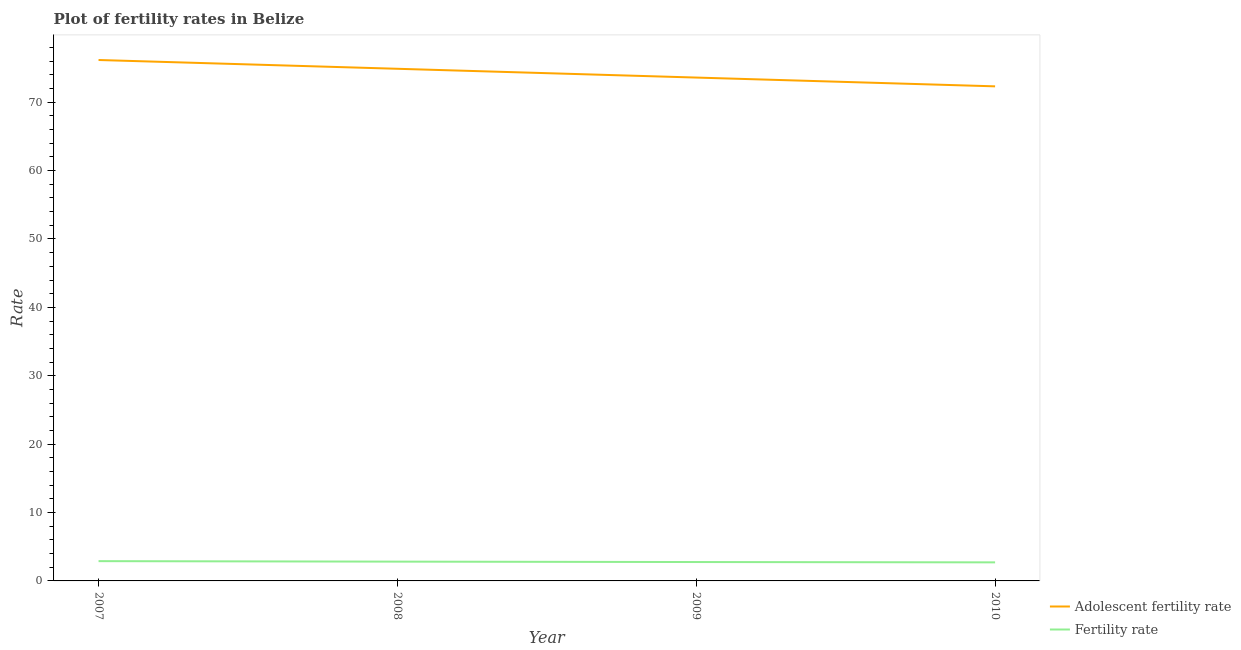How many different coloured lines are there?
Provide a short and direct response. 2. What is the fertility rate in 2009?
Your response must be concise. 2.76. Across all years, what is the maximum fertility rate?
Provide a succinct answer. 2.89. Across all years, what is the minimum fertility rate?
Your answer should be compact. 2.71. In which year was the fertility rate minimum?
Provide a succinct answer. 2010. What is the total adolescent fertility rate in the graph?
Provide a succinct answer. 296.97. What is the difference between the fertility rate in 2008 and that in 2010?
Your answer should be very brief. 0.11. What is the difference between the adolescent fertility rate in 2007 and the fertility rate in 2008?
Give a very brief answer. 73.35. What is the average adolescent fertility rate per year?
Keep it short and to the point. 74.24. In the year 2009, what is the difference between the fertility rate and adolescent fertility rate?
Provide a succinct answer. -70.84. In how many years, is the adolescent fertility rate greater than 2?
Ensure brevity in your answer.  4. What is the ratio of the adolescent fertility rate in 2009 to that in 2010?
Offer a very short reply. 1.02. What is the difference between the highest and the second highest adolescent fertility rate?
Give a very brief answer. 1.28. What is the difference between the highest and the lowest fertility rate?
Provide a short and direct response. 0.18. Is the sum of the adolescent fertility rate in 2007 and 2008 greater than the maximum fertility rate across all years?
Your response must be concise. Yes. Is the adolescent fertility rate strictly greater than the fertility rate over the years?
Provide a succinct answer. Yes. How many years are there in the graph?
Your response must be concise. 4. Does the graph contain any zero values?
Your response must be concise. No. Does the graph contain grids?
Provide a succinct answer. No. How many legend labels are there?
Your response must be concise. 2. What is the title of the graph?
Offer a terse response. Plot of fertility rates in Belize. What is the label or title of the Y-axis?
Offer a terse response. Rate. What is the Rate in Adolescent fertility rate in 2007?
Give a very brief answer. 76.17. What is the Rate in Fertility rate in 2007?
Provide a short and direct response. 2.89. What is the Rate in Adolescent fertility rate in 2008?
Keep it short and to the point. 74.89. What is the Rate in Fertility rate in 2008?
Provide a short and direct response. 2.82. What is the Rate in Adolescent fertility rate in 2009?
Give a very brief answer. 73.6. What is the Rate of Fertility rate in 2009?
Your answer should be very brief. 2.76. What is the Rate of Adolescent fertility rate in 2010?
Offer a terse response. 72.32. What is the Rate in Fertility rate in 2010?
Offer a terse response. 2.71. Across all years, what is the maximum Rate of Adolescent fertility rate?
Provide a short and direct response. 76.17. Across all years, what is the maximum Rate in Fertility rate?
Provide a succinct answer. 2.89. Across all years, what is the minimum Rate in Adolescent fertility rate?
Your answer should be compact. 72.32. Across all years, what is the minimum Rate in Fertility rate?
Offer a terse response. 2.71. What is the total Rate in Adolescent fertility rate in the graph?
Offer a very short reply. 296.97. What is the total Rate in Fertility rate in the graph?
Provide a short and direct response. 11.19. What is the difference between the Rate of Adolescent fertility rate in 2007 and that in 2008?
Provide a short and direct response. 1.28. What is the difference between the Rate in Fertility rate in 2007 and that in 2008?
Give a very brief answer. 0.07. What is the difference between the Rate of Adolescent fertility rate in 2007 and that in 2009?
Give a very brief answer. 2.57. What is the difference between the Rate of Fertility rate in 2007 and that in 2009?
Make the answer very short. 0.13. What is the difference between the Rate in Adolescent fertility rate in 2007 and that in 2010?
Offer a very short reply. 3.85. What is the difference between the Rate in Fertility rate in 2007 and that in 2010?
Give a very brief answer. 0.18. What is the difference between the Rate in Adolescent fertility rate in 2008 and that in 2009?
Offer a terse response. 1.28. What is the difference between the Rate in Fertility rate in 2008 and that in 2009?
Ensure brevity in your answer.  0.06. What is the difference between the Rate of Adolescent fertility rate in 2008 and that in 2010?
Offer a terse response. 2.57. What is the difference between the Rate of Fertility rate in 2008 and that in 2010?
Provide a succinct answer. 0.11. What is the difference between the Rate of Adolescent fertility rate in 2009 and that in 2010?
Offer a very short reply. 1.28. What is the difference between the Rate of Fertility rate in 2009 and that in 2010?
Your answer should be compact. 0.05. What is the difference between the Rate in Adolescent fertility rate in 2007 and the Rate in Fertility rate in 2008?
Your answer should be compact. 73.35. What is the difference between the Rate of Adolescent fertility rate in 2007 and the Rate of Fertility rate in 2009?
Your answer should be very brief. 73.41. What is the difference between the Rate of Adolescent fertility rate in 2007 and the Rate of Fertility rate in 2010?
Your response must be concise. 73.45. What is the difference between the Rate of Adolescent fertility rate in 2008 and the Rate of Fertility rate in 2009?
Offer a terse response. 72.12. What is the difference between the Rate in Adolescent fertility rate in 2008 and the Rate in Fertility rate in 2010?
Keep it short and to the point. 72.17. What is the difference between the Rate in Adolescent fertility rate in 2009 and the Rate in Fertility rate in 2010?
Offer a terse response. 70.89. What is the average Rate in Adolescent fertility rate per year?
Your answer should be very brief. 74.24. What is the average Rate of Fertility rate per year?
Your response must be concise. 2.8. In the year 2007, what is the difference between the Rate of Adolescent fertility rate and Rate of Fertility rate?
Make the answer very short. 73.28. In the year 2008, what is the difference between the Rate in Adolescent fertility rate and Rate in Fertility rate?
Keep it short and to the point. 72.06. In the year 2009, what is the difference between the Rate of Adolescent fertility rate and Rate of Fertility rate?
Your answer should be very brief. 70.84. In the year 2010, what is the difference between the Rate of Adolescent fertility rate and Rate of Fertility rate?
Offer a terse response. 69.6. What is the ratio of the Rate of Adolescent fertility rate in 2007 to that in 2008?
Make the answer very short. 1.02. What is the ratio of the Rate of Fertility rate in 2007 to that in 2008?
Ensure brevity in your answer.  1.03. What is the ratio of the Rate in Adolescent fertility rate in 2007 to that in 2009?
Offer a very short reply. 1.03. What is the ratio of the Rate in Fertility rate in 2007 to that in 2009?
Provide a short and direct response. 1.05. What is the ratio of the Rate of Adolescent fertility rate in 2007 to that in 2010?
Make the answer very short. 1.05. What is the ratio of the Rate of Fertility rate in 2007 to that in 2010?
Give a very brief answer. 1.07. What is the ratio of the Rate of Adolescent fertility rate in 2008 to that in 2009?
Your response must be concise. 1.02. What is the ratio of the Rate of Fertility rate in 2008 to that in 2009?
Provide a short and direct response. 1.02. What is the ratio of the Rate of Adolescent fertility rate in 2008 to that in 2010?
Your answer should be very brief. 1.04. What is the ratio of the Rate in Fertility rate in 2008 to that in 2010?
Your response must be concise. 1.04. What is the ratio of the Rate in Adolescent fertility rate in 2009 to that in 2010?
Your answer should be very brief. 1.02. What is the ratio of the Rate in Fertility rate in 2009 to that in 2010?
Offer a very short reply. 1.02. What is the difference between the highest and the second highest Rate of Adolescent fertility rate?
Make the answer very short. 1.28. What is the difference between the highest and the second highest Rate of Fertility rate?
Offer a terse response. 0.07. What is the difference between the highest and the lowest Rate in Adolescent fertility rate?
Give a very brief answer. 3.85. What is the difference between the highest and the lowest Rate in Fertility rate?
Offer a very short reply. 0.18. 